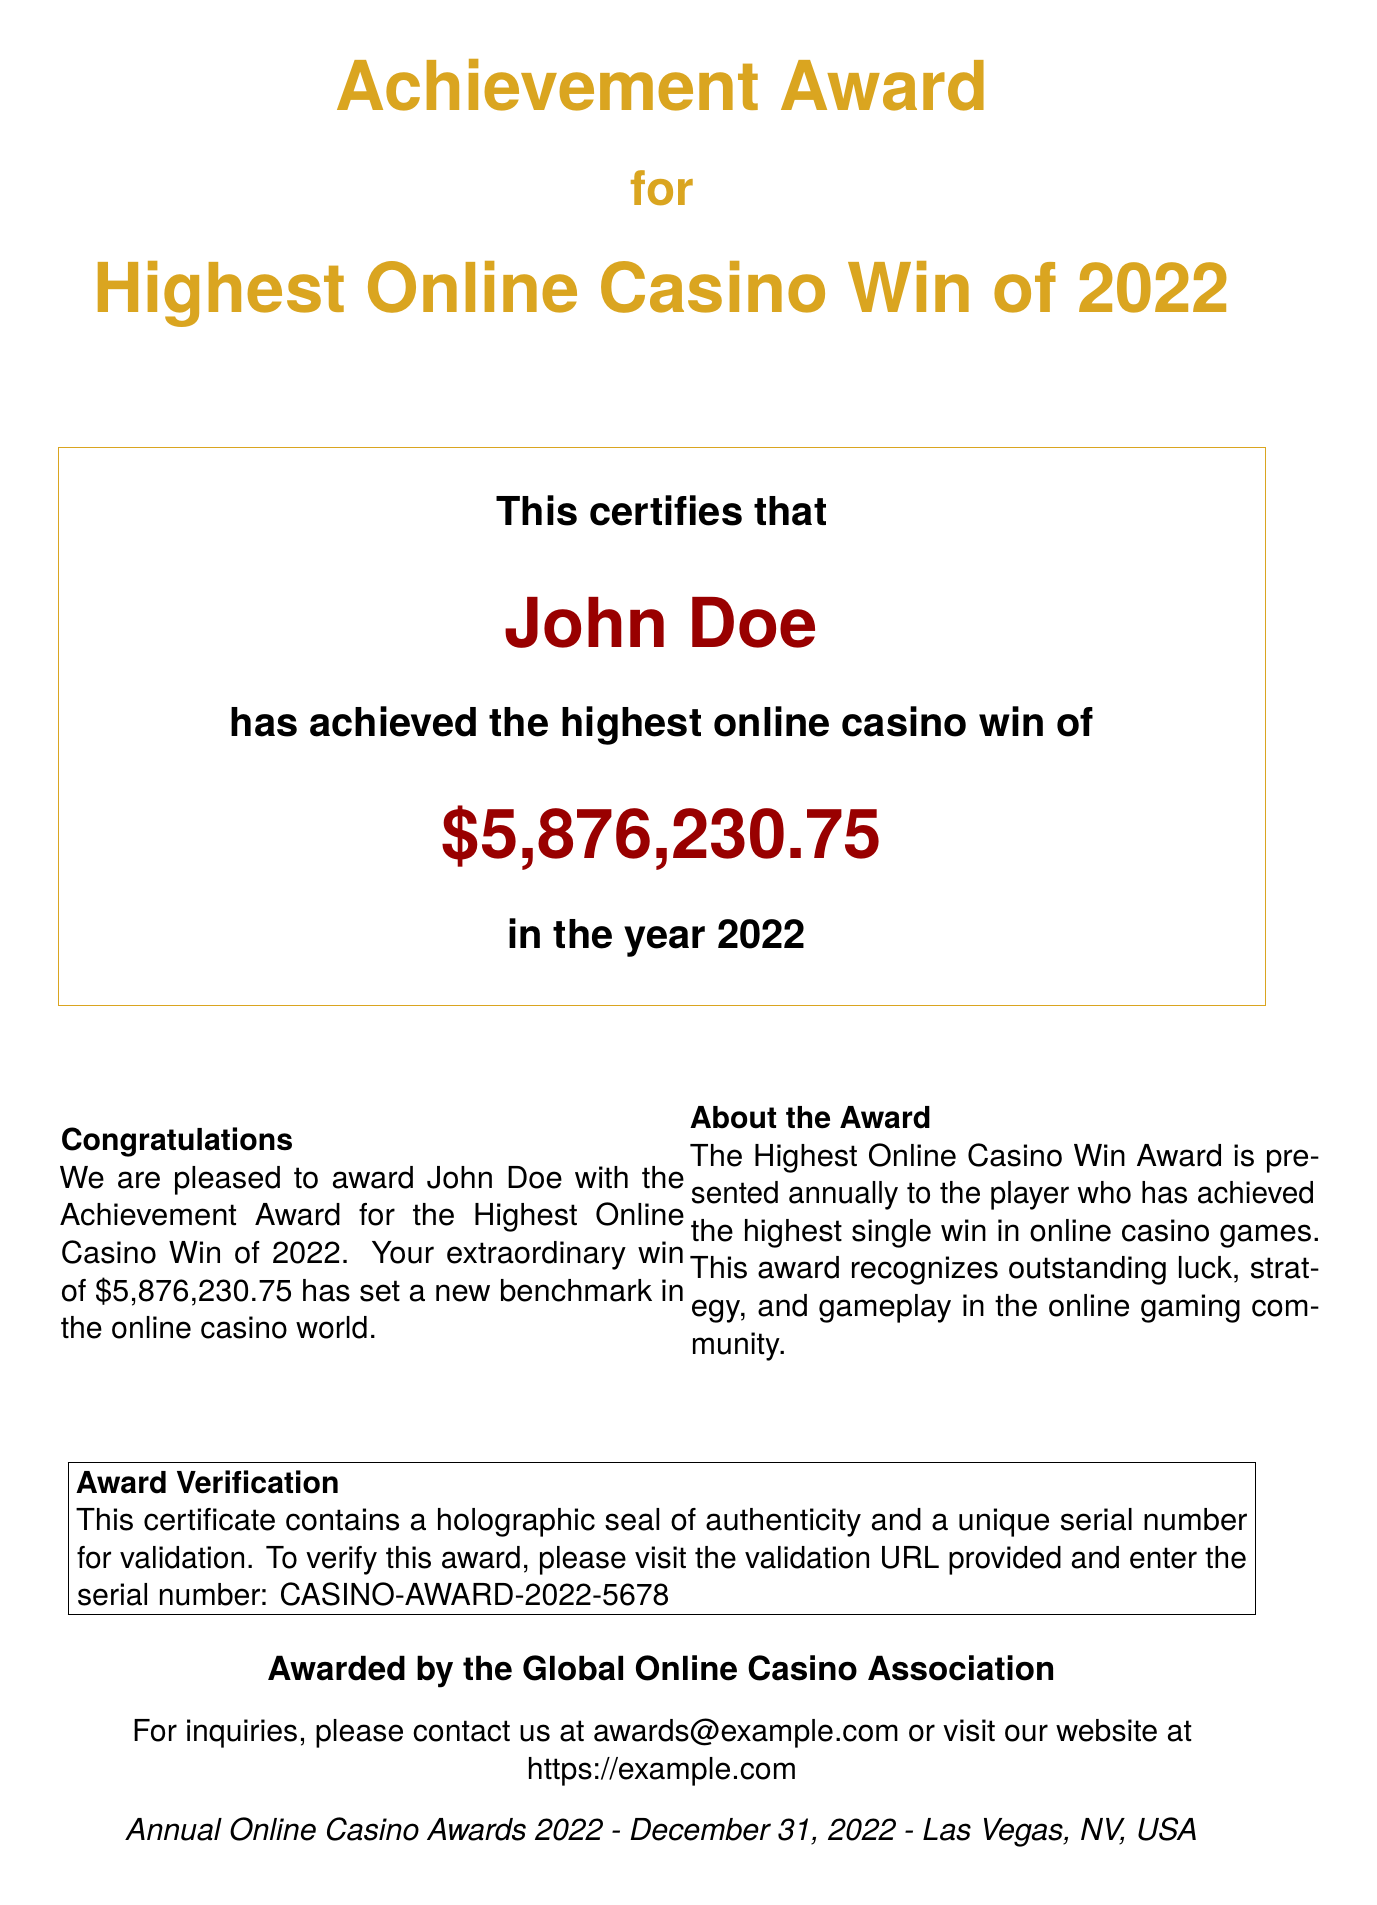What is the player's name? The player's name is clearly stated in the certificate as the individual who achieved the award.
Answer: John Doe What is the winning amount? The winning amount is prominently displayed in the certificate and represents the highest online casino win.
Answer: $5,876,230.75 What year does this award pertain to? The award is specified to be for the highest online casino win of a particular year, which is stated in the document.
Answer: 2022 Who awarded the certificate? The party responsible for awarding the certificate is mentioned at the bottom of the document.
Answer: Global Online Casino Association What type of seal is mentioned for verification? The document states the type of seal that assures the authenticity of the certificate.
Answer: holographic seal What is the unique serial number for verification? A unique serial number is provided for validating the award as part of its security features.
Answer: CASINO-AWARD-2022-5678 What is one of the reasons for the award? The award recognizes a specific achievement in the online gaming community, which is noted in the description.
Answer: outstanding luck, strategy, and gameplay In which city was the award presented? The certificate indicates the city where the awards ceremony took place.
Answer: Las Vegas When was the award ceremony held? The date of the awards event is given in the document, which is relevant to when the achievement was recognized.
Answer: December 31, 2022 What color is the border of the certificate? The color of the border is described in the document and is a defining visual characteristic.
Answer: goldembossed 